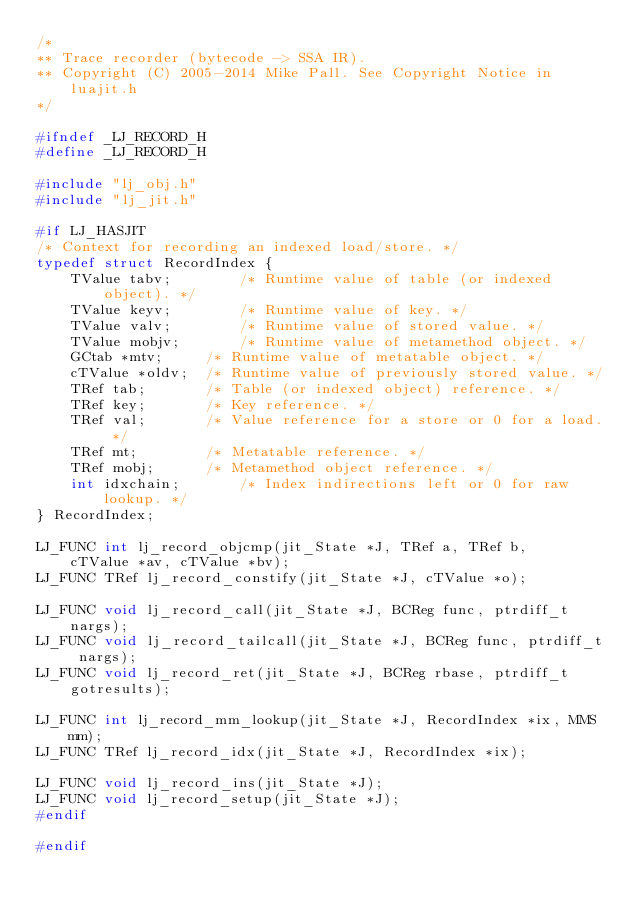Convert code to text. <code><loc_0><loc_0><loc_500><loc_500><_C_>/*
** Trace recorder (bytecode -> SSA IR).
** Copyright (C) 2005-2014 Mike Pall. See Copyright Notice in luajit.h
*/

#ifndef _LJ_RECORD_H
#define _LJ_RECORD_H

#include "lj_obj.h"
#include "lj_jit.h"

#if LJ_HASJIT
/* Context for recording an indexed load/store. */
typedef struct RecordIndex {
    TValue tabv;		/* Runtime value of table (or indexed object). */
    TValue keyv;		/* Runtime value of key. */
    TValue valv;		/* Runtime value of stored value. */
    TValue mobjv;		/* Runtime value of metamethod object. */
    GCtab *mtv;		/* Runtime value of metatable object. */
    cTValue *oldv;	/* Runtime value of previously stored value. */
    TRef tab;		/* Table (or indexed object) reference. */
    TRef key;		/* Key reference. */
    TRef val;		/* Value reference for a store or 0 for a load. */
    TRef mt;		/* Metatable reference. */
    TRef mobj;		/* Metamethod object reference. */
    int idxchain;		/* Index indirections left or 0 for raw lookup. */
} RecordIndex;

LJ_FUNC int lj_record_objcmp(jit_State *J, TRef a, TRef b,
    cTValue *av, cTValue *bv);
LJ_FUNC TRef lj_record_constify(jit_State *J, cTValue *o);

LJ_FUNC void lj_record_call(jit_State *J, BCReg func, ptrdiff_t nargs);
LJ_FUNC void lj_record_tailcall(jit_State *J, BCReg func, ptrdiff_t nargs);
LJ_FUNC void lj_record_ret(jit_State *J, BCReg rbase, ptrdiff_t gotresults);

LJ_FUNC int lj_record_mm_lookup(jit_State *J, RecordIndex *ix, MMS mm);
LJ_FUNC TRef lj_record_idx(jit_State *J, RecordIndex *ix);

LJ_FUNC void lj_record_ins(jit_State *J);
LJ_FUNC void lj_record_setup(jit_State *J);
#endif

#endif
</code> 